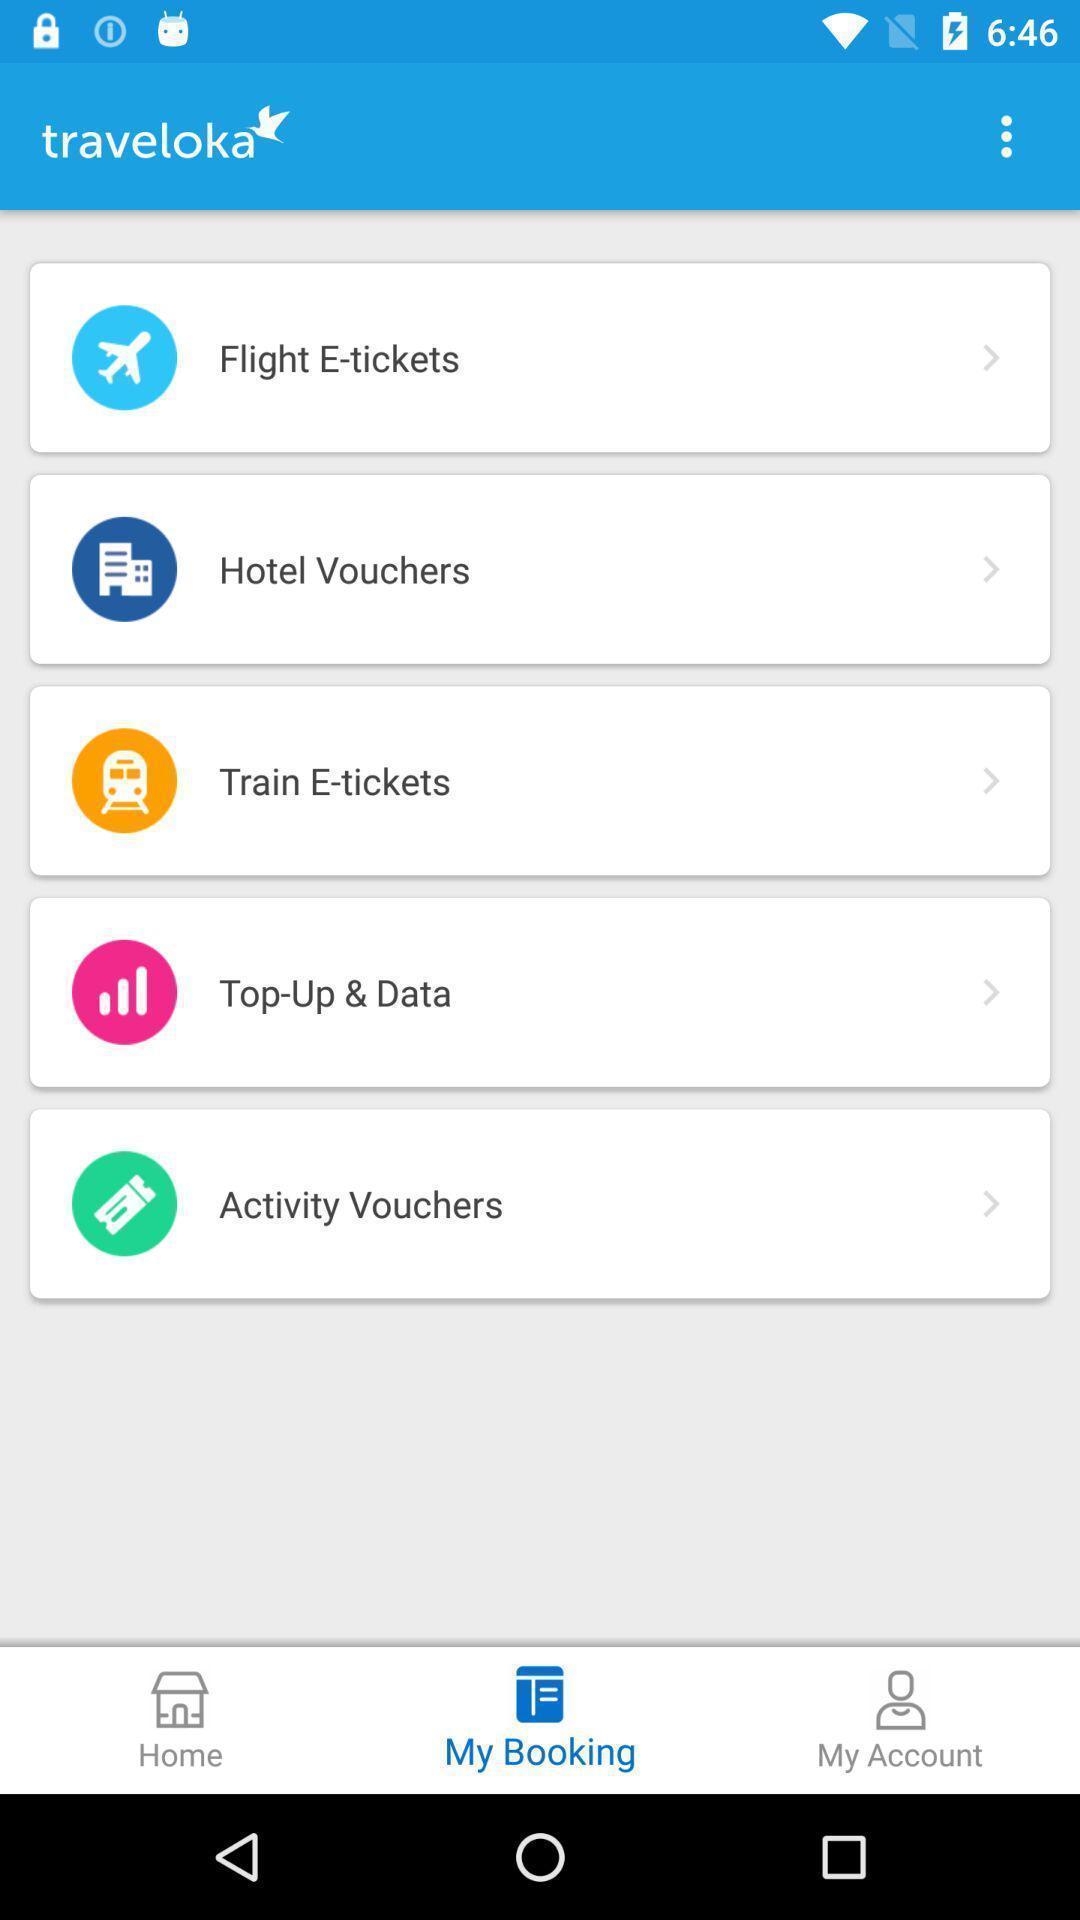Describe the key features of this screenshot. Screen showing my booking. 